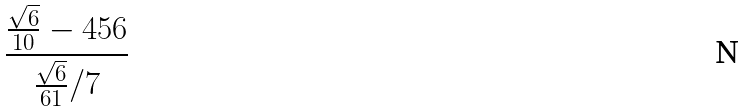<formula> <loc_0><loc_0><loc_500><loc_500>\frac { \frac { \sqrt { 6 } } { 1 0 } - 4 5 6 } { \frac { \sqrt { 6 } } { 6 1 } / 7 }</formula> 